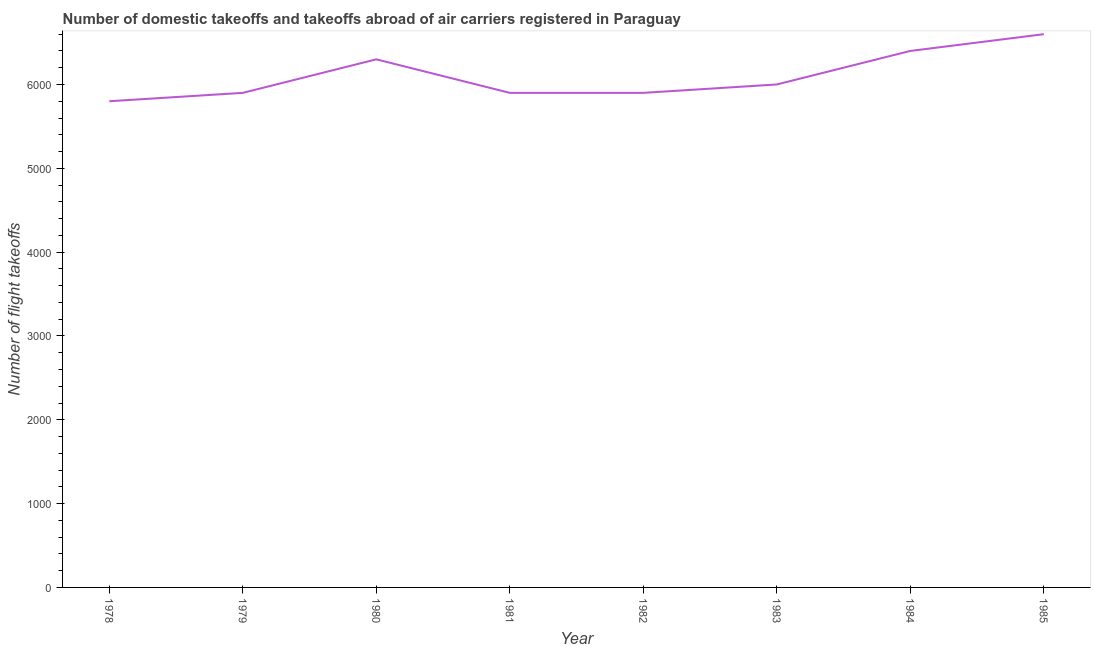What is the number of flight takeoffs in 1981?
Provide a succinct answer. 5900. Across all years, what is the maximum number of flight takeoffs?
Give a very brief answer. 6600. Across all years, what is the minimum number of flight takeoffs?
Give a very brief answer. 5800. In which year was the number of flight takeoffs minimum?
Provide a short and direct response. 1978. What is the sum of the number of flight takeoffs?
Your answer should be very brief. 4.88e+04. What is the difference between the number of flight takeoffs in 1979 and 1985?
Provide a succinct answer. -700. What is the average number of flight takeoffs per year?
Make the answer very short. 6100. What is the median number of flight takeoffs?
Your response must be concise. 5950. In how many years, is the number of flight takeoffs greater than 2800 ?
Keep it short and to the point. 8. What is the ratio of the number of flight takeoffs in 1981 to that in 1983?
Offer a very short reply. 0.98. Is the number of flight takeoffs in 1980 less than that in 1981?
Ensure brevity in your answer.  No. What is the difference between the highest and the second highest number of flight takeoffs?
Your response must be concise. 200. Is the sum of the number of flight takeoffs in 1978 and 1979 greater than the maximum number of flight takeoffs across all years?
Provide a short and direct response. Yes. What is the difference between the highest and the lowest number of flight takeoffs?
Your answer should be very brief. 800. How many lines are there?
Your answer should be compact. 1. How many years are there in the graph?
Offer a terse response. 8. What is the title of the graph?
Give a very brief answer. Number of domestic takeoffs and takeoffs abroad of air carriers registered in Paraguay. What is the label or title of the Y-axis?
Provide a succinct answer. Number of flight takeoffs. What is the Number of flight takeoffs in 1978?
Offer a very short reply. 5800. What is the Number of flight takeoffs of 1979?
Provide a succinct answer. 5900. What is the Number of flight takeoffs of 1980?
Offer a very short reply. 6300. What is the Number of flight takeoffs in 1981?
Provide a succinct answer. 5900. What is the Number of flight takeoffs of 1982?
Your answer should be very brief. 5900. What is the Number of flight takeoffs of 1983?
Provide a short and direct response. 6000. What is the Number of flight takeoffs of 1984?
Your answer should be very brief. 6400. What is the Number of flight takeoffs in 1985?
Make the answer very short. 6600. What is the difference between the Number of flight takeoffs in 1978 and 1979?
Provide a short and direct response. -100. What is the difference between the Number of flight takeoffs in 1978 and 1980?
Offer a terse response. -500. What is the difference between the Number of flight takeoffs in 1978 and 1981?
Give a very brief answer. -100. What is the difference between the Number of flight takeoffs in 1978 and 1982?
Your answer should be very brief. -100. What is the difference between the Number of flight takeoffs in 1978 and 1983?
Offer a terse response. -200. What is the difference between the Number of flight takeoffs in 1978 and 1984?
Offer a terse response. -600. What is the difference between the Number of flight takeoffs in 1978 and 1985?
Give a very brief answer. -800. What is the difference between the Number of flight takeoffs in 1979 and 1980?
Offer a very short reply. -400. What is the difference between the Number of flight takeoffs in 1979 and 1982?
Your answer should be very brief. 0. What is the difference between the Number of flight takeoffs in 1979 and 1983?
Your answer should be very brief. -100. What is the difference between the Number of flight takeoffs in 1979 and 1984?
Provide a succinct answer. -500. What is the difference between the Number of flight takeoffs in 1979 and 1985?
Your answer should be very brief. -700. What is the difference between the Number of flight takeoffs in 1980 and 1981?
Offer a very short reply. 400. What is the difference between the Number of flight takeoffs in 1980 and 1982?
Keep it short and to the point. 400. What is the difference between the Number of flight takeoffs in 1980 and 1983?
Your answer should be very brief. 300. What is the difference between the Number of flight takeoffs in 1980 and 1984?
Offer a terse response. -100. What is the difference between the Number of flight takeoffs in 1980 and 1985?
Your answer should be compact. -300. What is the difference between the Number of flight takeoffs in 1981 and 1983?
Your answer should be very brief. -100. What is the difference between the Number of flight takeoffs in 1981 and 1984?
Keep it short and to the point. -500. What is the difference between the Number of flight takeoffs in 1981 and 1985?
Your answer should be very brief. -700. What is the difference between the Number of flight takeoffs in 1982 and 1983?
Ensure brevity in your answer.  -100. What is the difference between the Number of flight takeoffs in 1982 and 1984?
Provide a succinct answer. -500. What is the difference between the Number of flight takeoffs in 1982 and 1985?
Your answer should be very brief. -700. What is the difference between the Number of flight takeoffs in 1983 and 1984?
Make the answer very short. -400. What is the difference between the Number of flight takeoffs in 1983 and 1985?
Offer a terse response. -600. What is the difference between the Number of flight takeoffs in 1984 and 1985?
Provide a short and direct response. -200. What is the ratio of the Number of flight takeoffs in 1978 to that in 1980?
Your response must be concise. 0.92. What is the ratio of the Number of flight takeoffs in 1978 to that in 1981?
Offer a very short reply. 0.98. What is the ratio of the Number of flight takeoffs in 1978 to that in 1984?
Offer a terse response. 0.91. What is the ratio of the Number of flight takeoffs in 1978 to that in 1985?
Your answer should be compact. 0.88. What is the ratio of the Number of flight takeoffs in 1979 to that in 1980?
Keep it short and to the point. 0.94. What is the ratio of the Number of flight takeoffs in 1979 to that in 1981?
Give a very brief answer. 1. What is the ratio of the Number of flight takeoffs in 1979 to that in 1983?
Your answer should be very brief. 0.98. What is the ratio of the Number of flight takeoffs in 1979 to that in 1984?
Make the answer very short. 0.92. What is the ratio of the Number of flight takeoffs in 1979 to that in 1985?
Provide a succinct answer. 0.89. What is the ratio of the Number of flight takeoffs in 1980 to that in 1981?
Ensure brevity in your answer.  1.07. What is the ratio of the Number of flight takeoffs in 1980 to that in 1982?
Your answer should be compact. 1.07. What is the ratio of the Number of flight takeoffs in 1980 to that in 1984?
Offer a very short reply. 0.98. What is the ratio of the Number of flight takeoffs in 1980 to that in 1985?
Ensure brevity in your answer.  0.95. What is the ratio of the Number of flight takeoffs in 1981 to that in 1983?
Provide a succinct answer. 0.98. What is the ratio of the Number of flight takeoffs in 1981 to that in 1984?
Give a very brief answer. 0.92. What is the ratio of the Number of flight takeoffs in 1981 to that in 1985?
Your answer should be compact. 0.89. What is the ratio of the Number of flight takeoffs in 1982 to that in 1983?
Give a very brief answer. 0.98. What is the ratio of the Number of flight takeoffs in 1982 to that in 1984?
Your response must be concise. 0.92. What is the ratio of the Number of flight takeoffs in 1982 to that in 1985?
Keep it short and to the point. 0.89. What is the ratio of the Number of flight takeoffs in 1983 to that in 1984?
Make the answer very short. 0.94. What is the ratio of the Number of flight takeoffs in 1983 to that in 1985?
Your answer should be very brief. 0.91. What is the ratio of the Number of flight takeoffs in 1984 to that in 1985?
Offer a terse response. 0.97. 